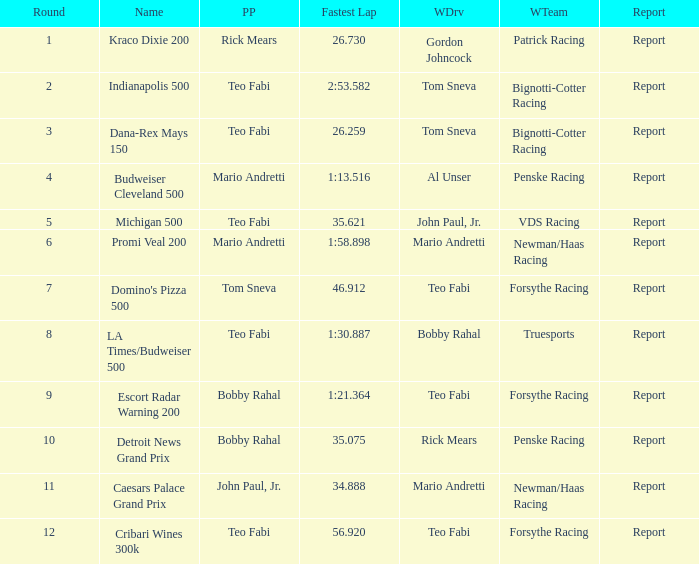How many winning drivers were there in the race that had a fastest lap time of 56.920? 1.0. 